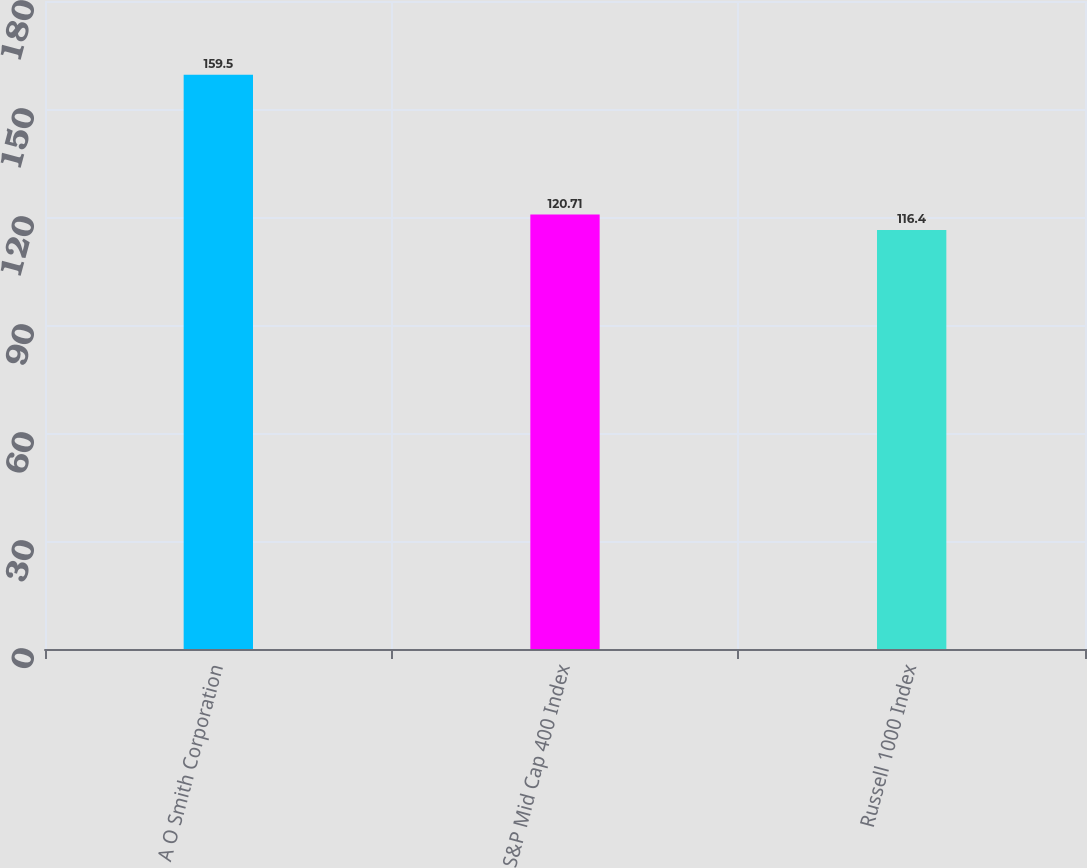Convert chart. <chart><loc_0><loc_0><loc_500><loc_500><bar_chart><fcel>A O Smith Corporation<fcel>S&P Mid Cap 400 Index<fcel>Russell 1000 Index<nl><fcel>159.5<fcel>120.71<fcel>116.4<nl></chart> 